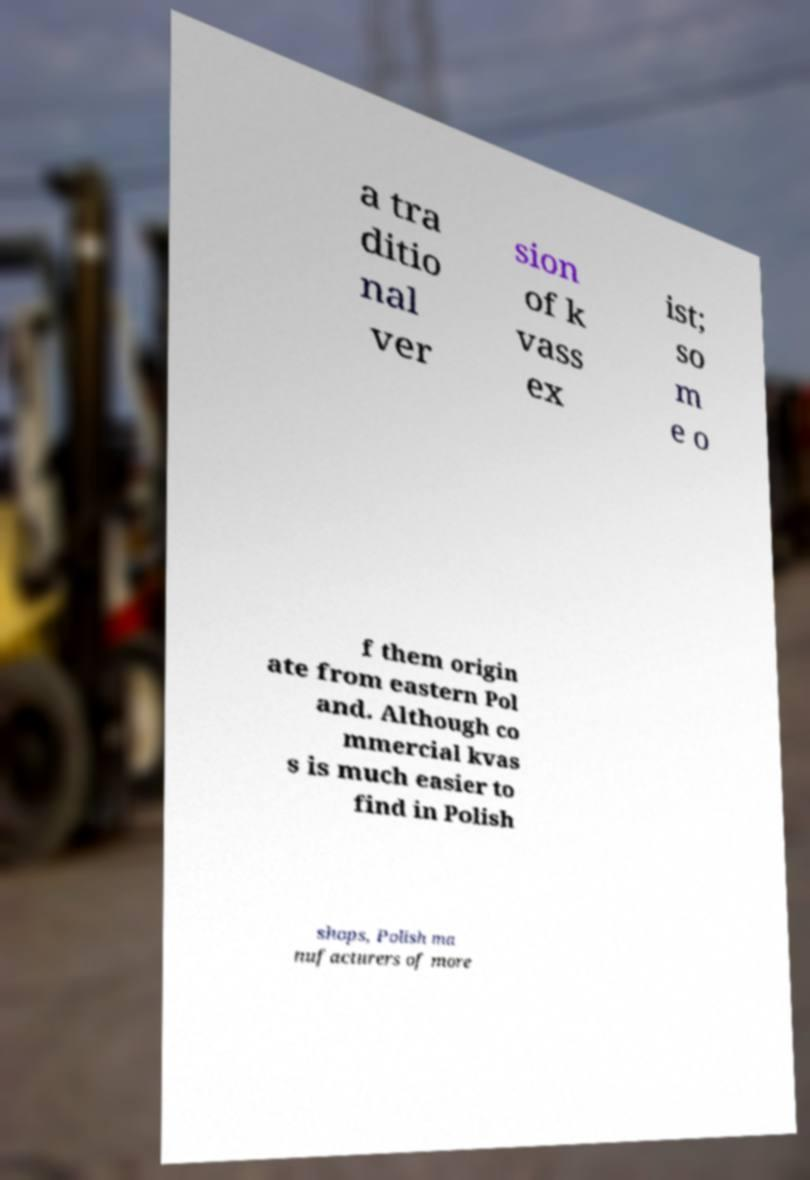Can you accurately transcribe the text from the provided image for me? a tra ditio nal ver sion of k vass ex ist; so m e o f them origin ate from eastern Pol and. Although co mmercial kvas s is much easier to find in Polish shops, Polish ma nufacturers of more 